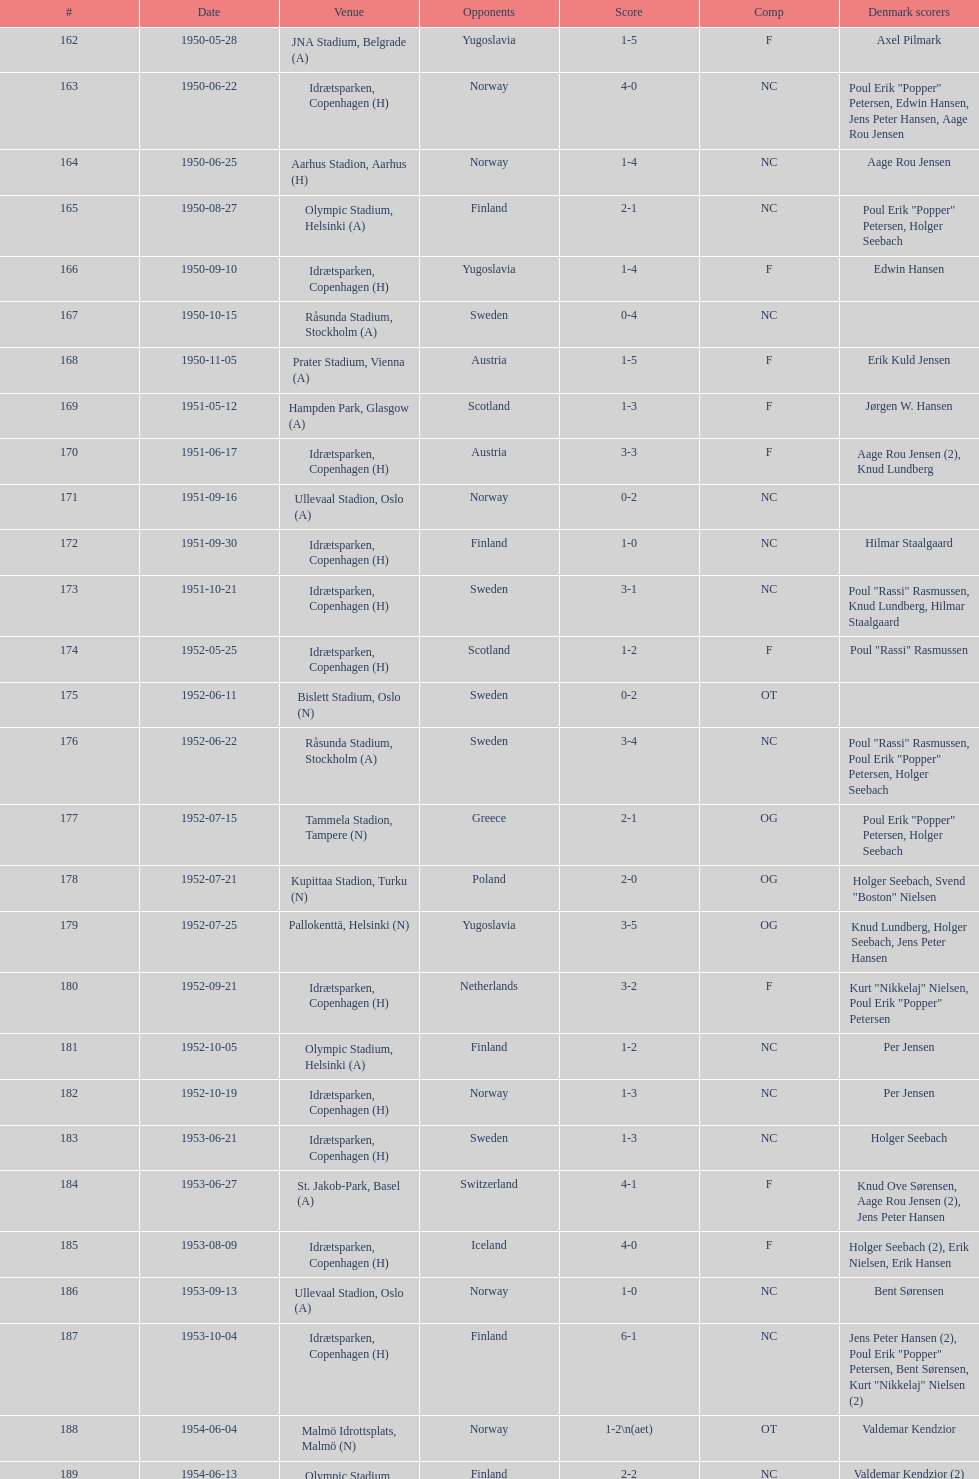What is the name of the venue listed before olympic stadium on 1950-08-27? Aarhus Stadion, Aarhus. 